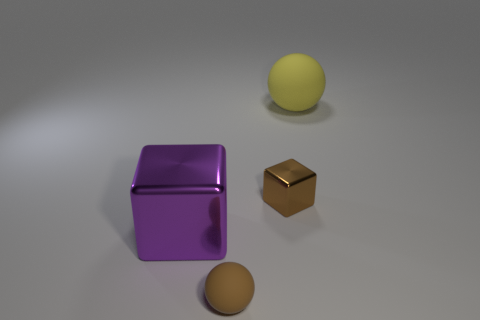The big rubber thing is what color?
Keep it short and to the point. Yellow. Is the purple shiny object the same size as the brown metallic thing?
Offer a terse response. No. Is the tiny brown block made of the same material as the ball that is to the left of the large matte thing?
Make the answer very short. No. There is a matte sphere in front of the large purple metallic object; does it have the same color as the tiny metallic object?
Offer a very short reply. Yes. How many things are behind the small brown matte sphere and in front of the small shiny block?
Offer a terse response. 1. What number of other things are made of the same material as the yellow sphere?
Your answer should be very brief. 1. Is the material of the small thing in front of the small brown cube the same as the purple block?
Your response must be concise. No. There is a rubber sphere that is in front of the big ball on the right side of the brown thing that is behind the purple block; what size is it?
Make the answer very short. Small. How many other things are the same color as the large rubber sphere?
Give a very brief answer. 0. What shape is the purple shiny object that is the same size as the yellow rubber sphere?
Your answer should be very brief. Cube. 